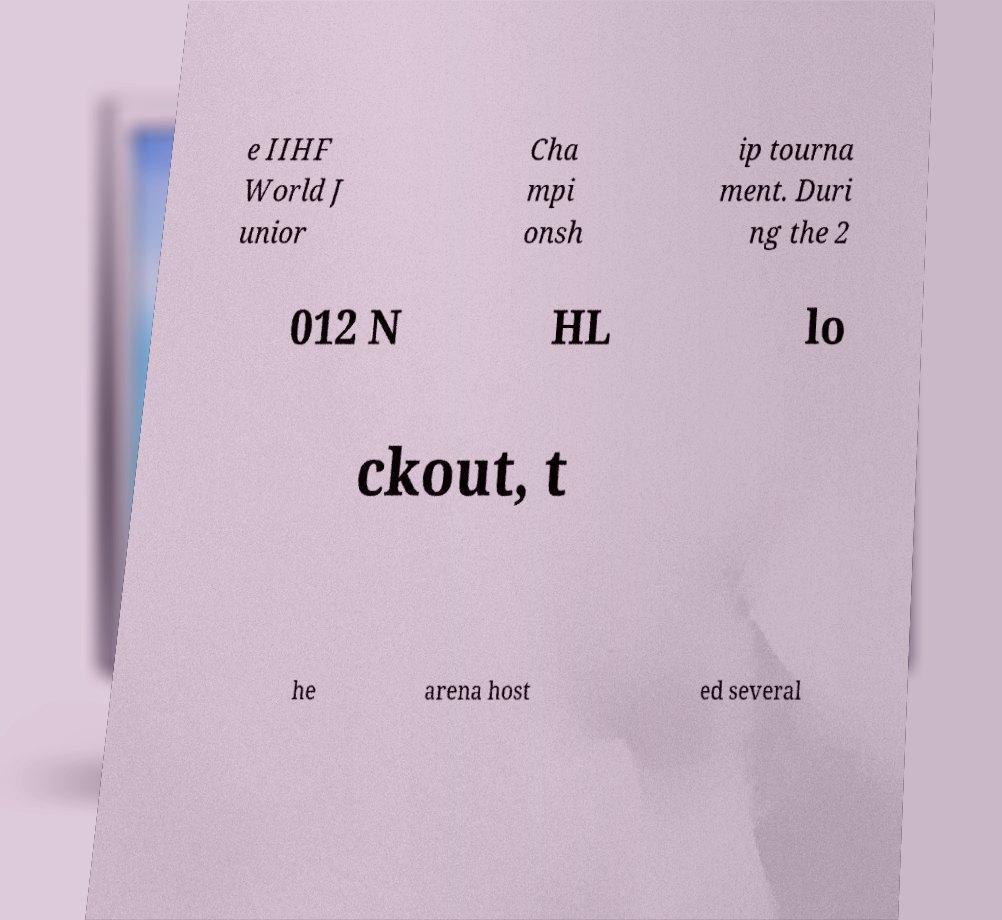What messages or text are displayed in this image? I need them in a readable, typed format. e IIHF World J unior Cha mpi onsh ip tourna ment. Duri ng the 2 012 N HL lo ckout, t he arena host ed several 